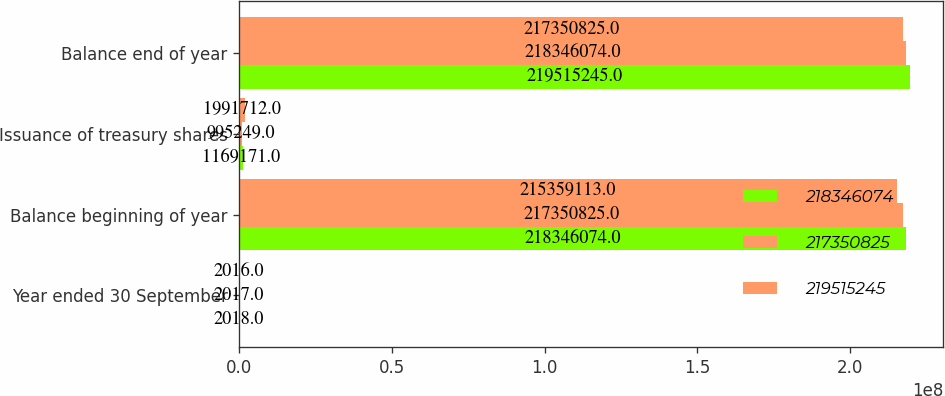Convert chart. <chart><loc_0><loc_0><loc_500><loc_500><stacked_bar_chart><ecel><fcel>Year ended 30 September<fcel>Balance beginning of year<fcel>Issuance of treasury shares<fcel>Balance end of year<nl><fcel>2.18346e+08<fcel>2018<fcel>2.18346e+08<fcel>1.16917e+06<fcel>2.19515e+08<nl><fcel>2.17351e+08<fcel>2017<fcel>2.17351e+08<fcel>995249<fcel>2.18346e+08<nl><fcel>2.19515e+08<fcel>2016<fcel>2.15359e+08<fcel>1.99171e+06<fcel>2.17351e+08<nl></chart> 